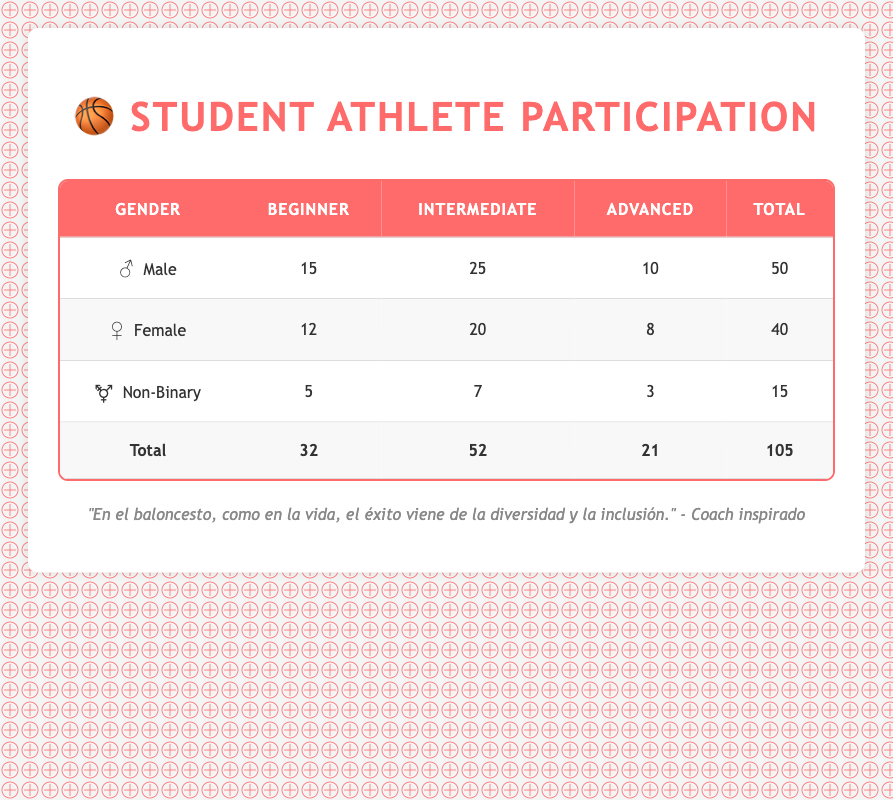What is the total number of male student athletes? According to the table, the total number of male student athletes is found in the "Total" column for males. Adding the counts of all experiences for males: 15 (Beginner) + 25 (Intermediate) + 10 (Advanced) = 50.
Answer: 50 How many female student athletes have advanced experience? In the table, under the "Female" row, the count for "Advanced" experience is listed. It shows a count of 8.
Answer: 8 Is there a higher number of beginner male players compared to beginner female players? To answer this, we check the counts for beginner players: Male has 15 and Female has 12. Since 15 (Male) is greater than 12 (Female), the statement is true.
Answer: Yes What is the average number of intermediate experience student athletes across all genders? We calculate the average by summing the counts for intermediate experience of all genders: 25 (Male) + 20 (Female) + 7 (Non-Binary) = 52. There are 3 groups, so we divide 52 by 3 (52/3 = 17.33).
Answer: 17.33 How many non-binary student athletes participated in basketball at any level of experience? The total number of non-binary student athletes is calculated by adding all counts for non-binary players: 5 (Beginner) + 7 (Intermediate) + 3 (Advanced) = 15.
Answer: 15 What gender has the lowest total participation in basketball? We compare the total counts for each gender from the table: Male = 50, Female = 40, Non-Binary = 15. The non-binary group has the lowest total.
Answer: Non-Binary If we combined the beginner and intermediate counts for female student athletes, how many would that be? We look at the "Female" row and sum beginner and intermediate counts: 12 (Beginner) + 20 (Intermediate) = 32.
Answer: 32 Are there more advanced male players than advanced non-binary players? The advanced count for males is 10 and for non-binary is 3. Comparing these figures, 10 is greater than 3, so the statement is true.
Answer: Yes What is the total number of beginner athletes across all genders? We sum up the "Beginner" counts for all groups: 15 (Male) + 12 (Female) + 5 (Non-Binary) = 32.
Answer: 32 